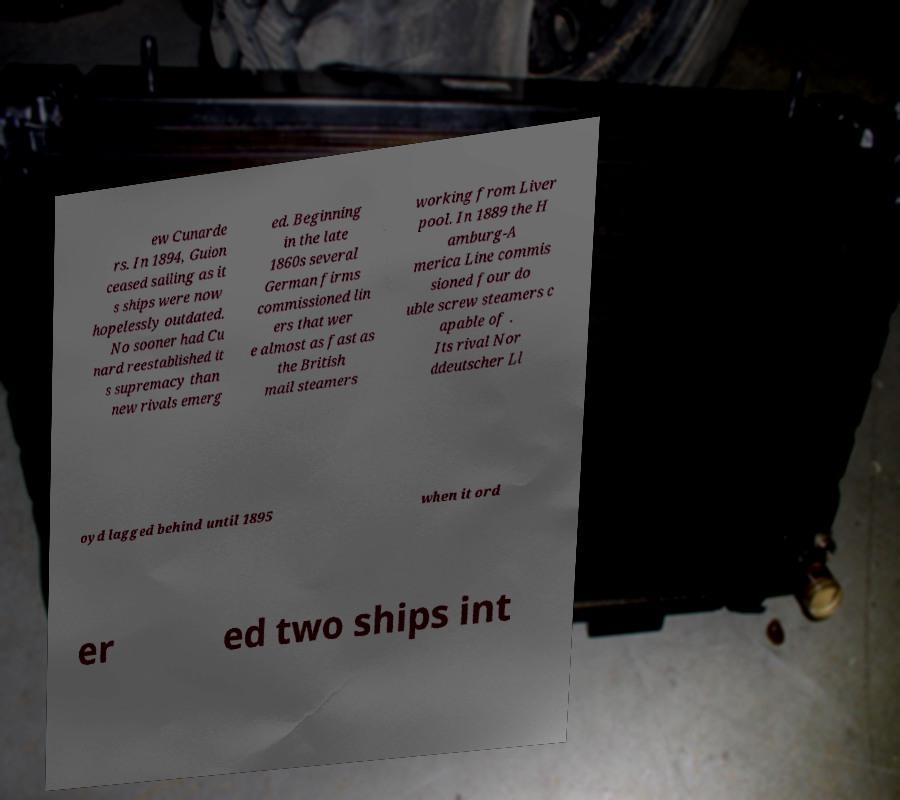For documentation purposes, I need the text within this image transcribed. Could you provide that? ew Cunarde rs. In 1894, Guion ceased sailing as it s ships were now hopelessly outdated. No sooner had Cu nard reestablished it s supremacy than new rivals emerg ed. Beginning in the late 1860s several German firms commissioned lin ers that wer e almost as fast as the British mail steamers working from Liver pool. In 1889 the H amburg-A merica Line commis sioned four do uble screw steamers c apable of . Its rival Nor ddeutscher Ll oyd lagged behind until 1895 when it ord er ed two ships int 